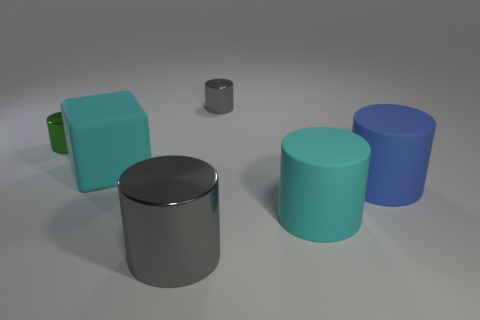Subtract 1 cylinders. How many cylinders are left? 4 Subtract all green cylinders. How many cylinders are left? 4 Subtract all green metal cylinders. How many cylinders are left? 4 Add 3 large brown matte cylinders. How many objects exist? 9 Subtract all cyan cylinders. Subtract all gray blocks. How many cylinders are left? 4 Subtract all cubes. How many objects are left? 5 Add 4 matte blocks. How many matte blocks exist? 5 Subtract 0 red blocks. How many objects are left? 6 Subtract all large spheres. Subtract all cyan blocks. How many objects are left? 5 Add 6 cubes. How many cubes are left? 7 